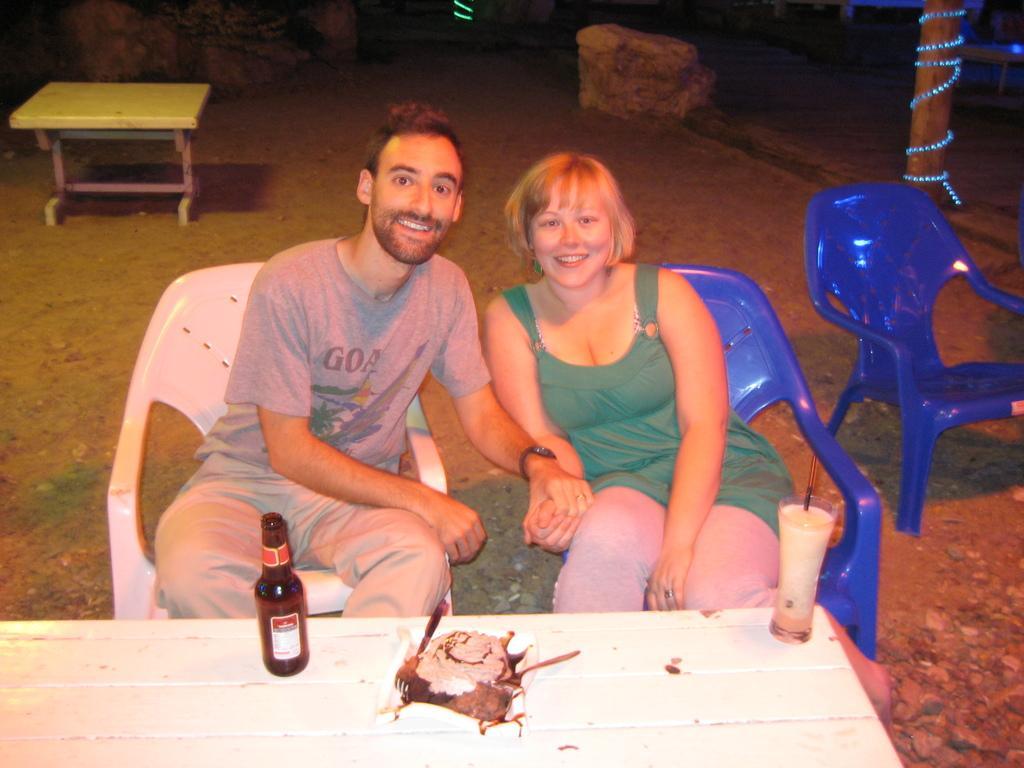Describe this image in one or two sentences. A couple are posing to camera sitting in chairs at a table with a bottle,a plate with food and a glass on it. 